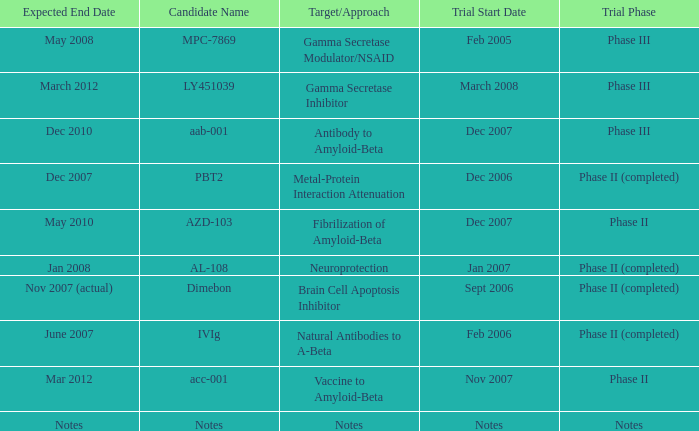Can you give me this table as a dict? {'header': ['Expected End Date', 'Candidate Name', 'Target/Approach', 'Trial Start Date', 'Trial Phase'], 'rows': [['May 2008', 'MPC-7869', 'Gamma Secretase Modulator/NSAID', 'Feb 2005', 'Phase III'], ['March 2012', 'LY451039', 'Gamma Secretase Inhibitor', 'March 2008', 'Phase III'], ['Dec 2010', 'aab-001', 'Antibody to Amyloid-Beta', 'Dec 2007', 'Phase III'], ['Dec 2007', 'PBT2', 'Metal-Protein Interaction Attenuation', 'Dec 2006', 'Phase II (completed)'], ['May 2010', 'AZD-103', 'Fibrilization of Amyloid-Beta', 'Dec 2007', 'Phase II'], ['Jan 2008', 'AL-108', 'Neuroprotection', 'Jan 2007', 'Phase II (completed)'], ['Nov 2007 (actual)', 'Dimebon', 'Brain Cell Apoptosis Inhibitor', 'Sept 2006', 'Phase II (completed)'], ['June 2007', 'IVIg', 'Natural Antibodies to A-Beta', 'Feb 2006', 'Phase II (completed)'], ['Mar 2012', 'acc-001', 'Vaccine to Amyloid-Beta', 'Nov 2007', 'Phase II'], ['Notes', 'Notes', 'Notes', 'Notes', 'Notes']]} What is Trial Start Date, when Candidate Name is Notes? Notes. 